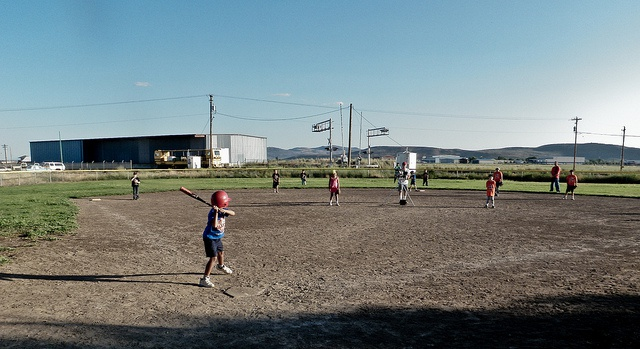Describe the objects in this image and their specific colors. I can see people in lightblue, black, gray, navy, and lightgray tones, people in lightblue, gray, black, and darkgreen tones, people in lightblue, black, maroon, and gray tones, people in lightblue, black, darkgray, gray, and olive tones, and people in lightblue, gray, black, darkgray, and lightgray tones in this image. 